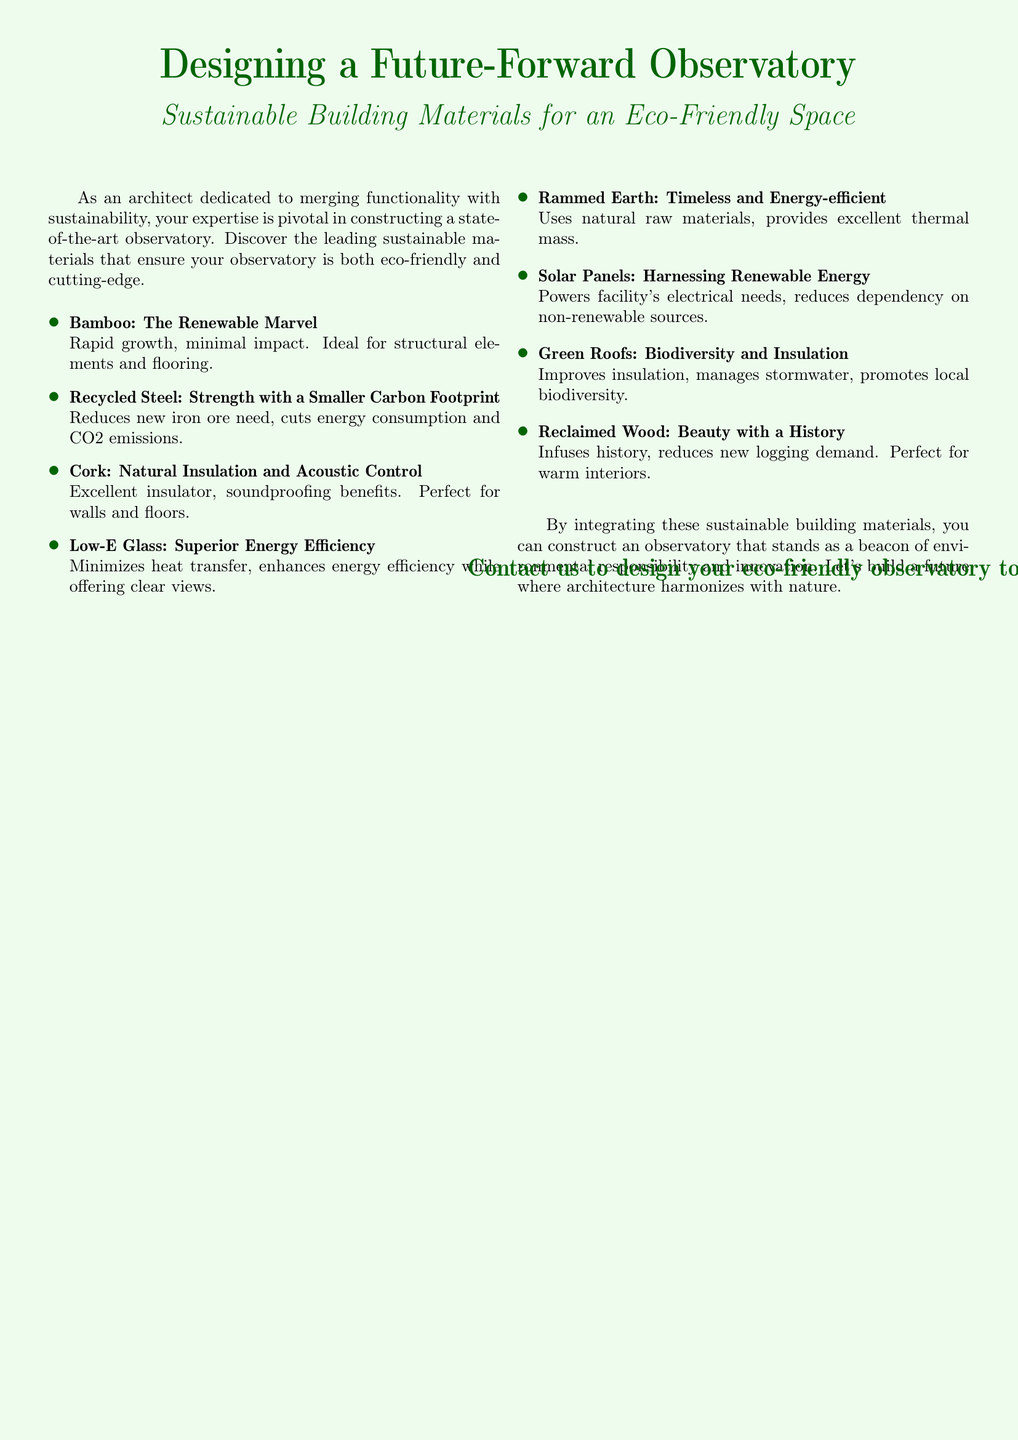What are two sustainable materials listed? The advertisement mentions several sustainable materials, including bamboo and recycled steel.
Answer: bamboo, recycled steel What is the main theme of the document? The document focuses on sustainable building materials for eco-friendly construction related to an observatory.
Answer: Sustainable building materials Which sustainable material is known for natural insulation? Cork is highlighted in the document for its excellent insulation and soundproofing benefits.
Answer: Cork What energy source is suggested for the observatory? The advertisement suggests using solar panels to harness renewable energy for the observatory.
Answer: Solar Panels What benefit does Low-E Glass provide? Low-E Glass is designed to minimize heat transfer and enhance energy efficiency, while providing clear views.
Answer: Superior energy efficiency What type of material is rammed earth categorized as? Rammed earth uses natural raw materials and is mentioned as timeless and energy-efficient.
Answer: Natural raw materials, energy-efficient What is the purpose of green roofs according to the document? Green roofs improve insulation, manage stormwater, and promote local biodiversity.
Answer: Biodiversity and insulation What feature does reclaimed wood provide? Reclaimed wood is said to infuse history and reduce the demand for new logging, perfect for creating warm interiors.
Answer: Beauty with a history 